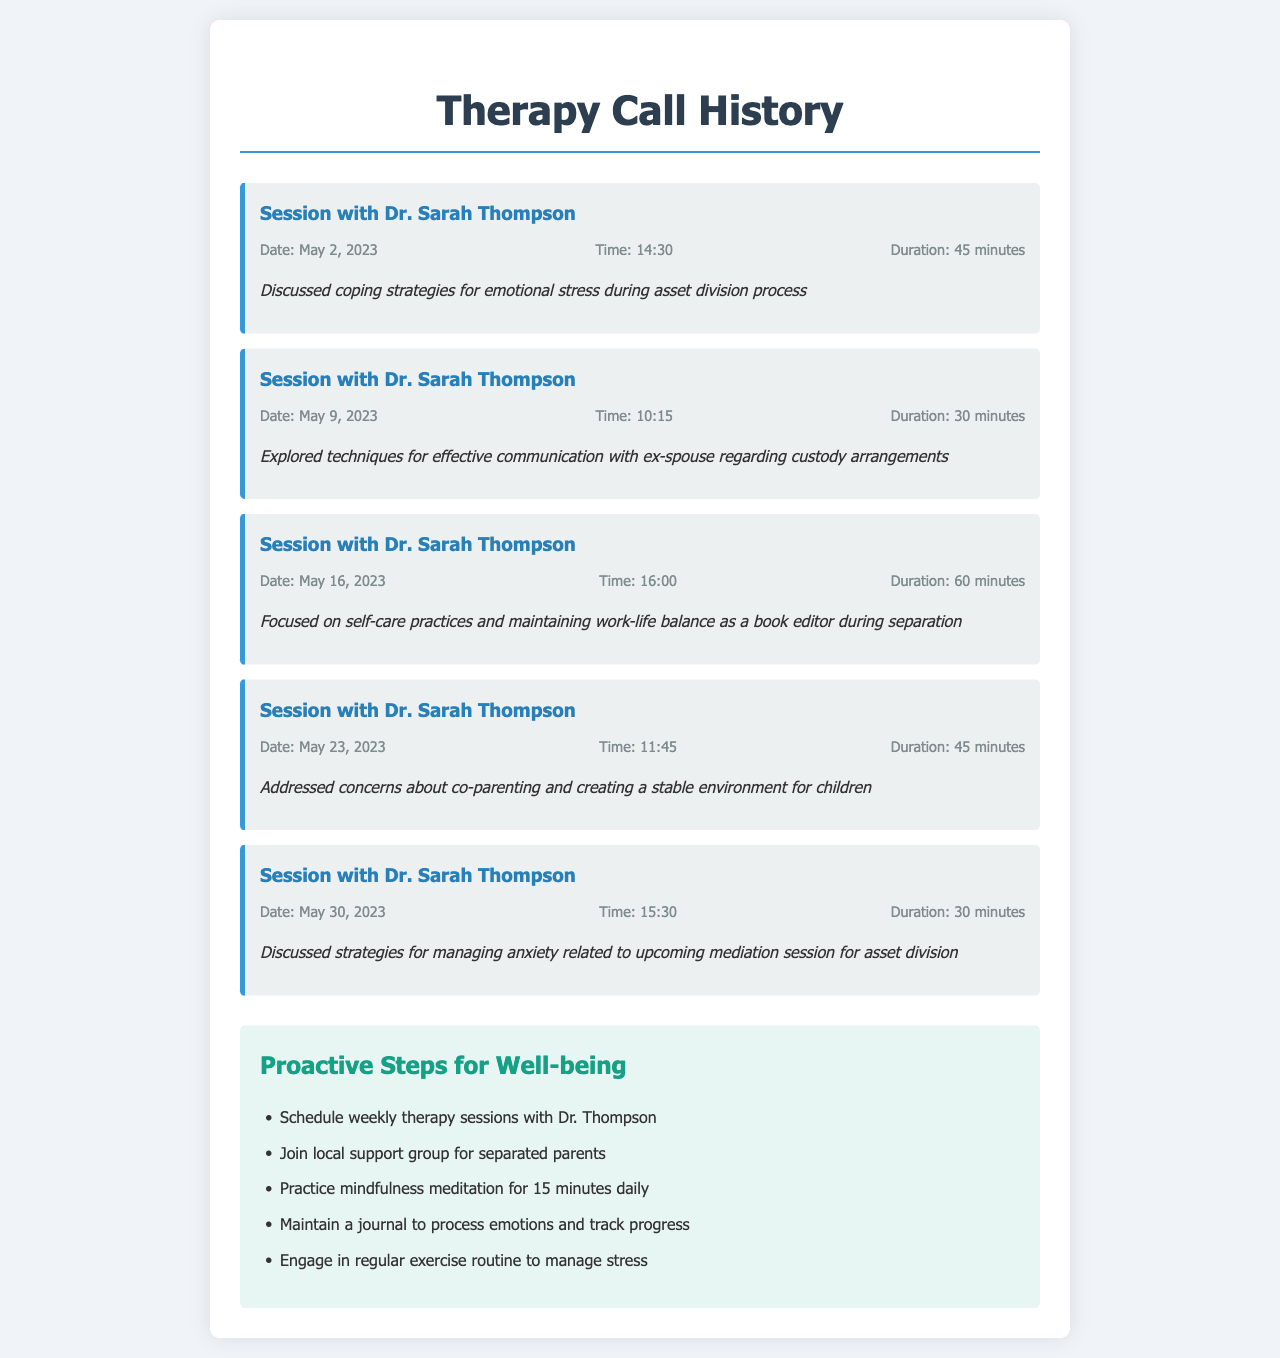What is the name of the counselor? The counselor's name is mentioned at the beginning of each session entry, which is Dr. Sarah Thompson.
Answer: Dr. Sarah Thompson How long was the longest session? The document lists the durations of sessions, with the longest being 60 minutes.
Answer: 60 minutes What date did the first session take place? The first session can be identified by the date listed in the first call entry, which is May 2, 2023.
Answer: May 2, 2023 What emotional strategy was discussed in the session on May 30, 2023? The call notes provide insights into specific discussions, with anxiety management strategies mentioned for this date.
Answer: Managing anxiety How many total sessions are recorded? Counting the call entries, there are a total of five recorded sessions in the document.
Answer: 5 What proactive step involves journaling? The proactive steps section includes maintaining a journal to help process emotions and track progress.
Answer: Maintain a journal What topic was addressed on May 23, 2023? The call notes for this session mention co-parenting concerns and creating a stable environment for children.
Answer: Co-parenting How often should therapy sessions be scheduled according to the proactive steps? The proactive steps specifically suggest scheduling weekly therapy sessions.
Answer: Weekly What type of group should be joined as per proactive steps? The document suggests joining a local support group aimed at separated parents.
Answer: Local support group 